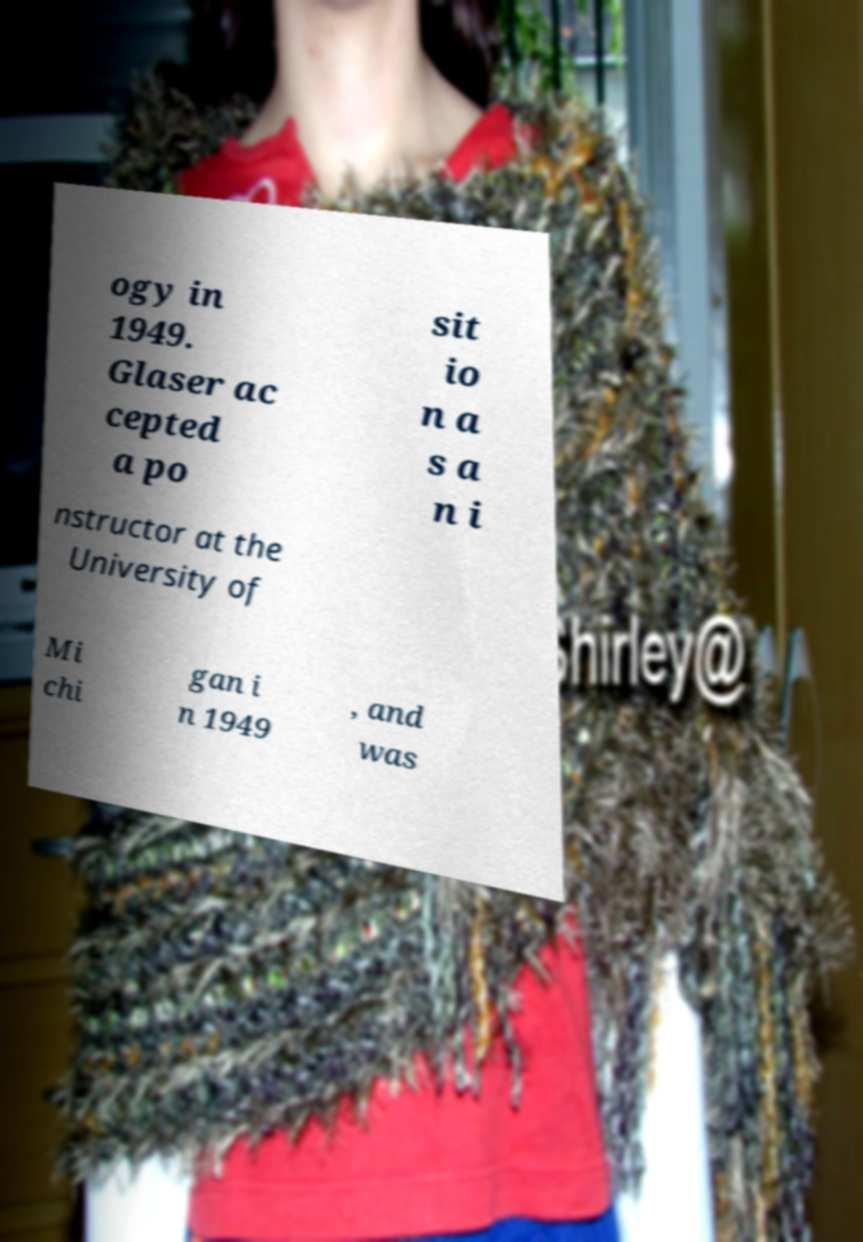What messages or text are displayed in this image? I need them in a readable, typed format. ogy in 1949. Glaser ac cepted a po sit io n a s a n i nstructor at the University of Mi chi gan i n 1949 , and was 